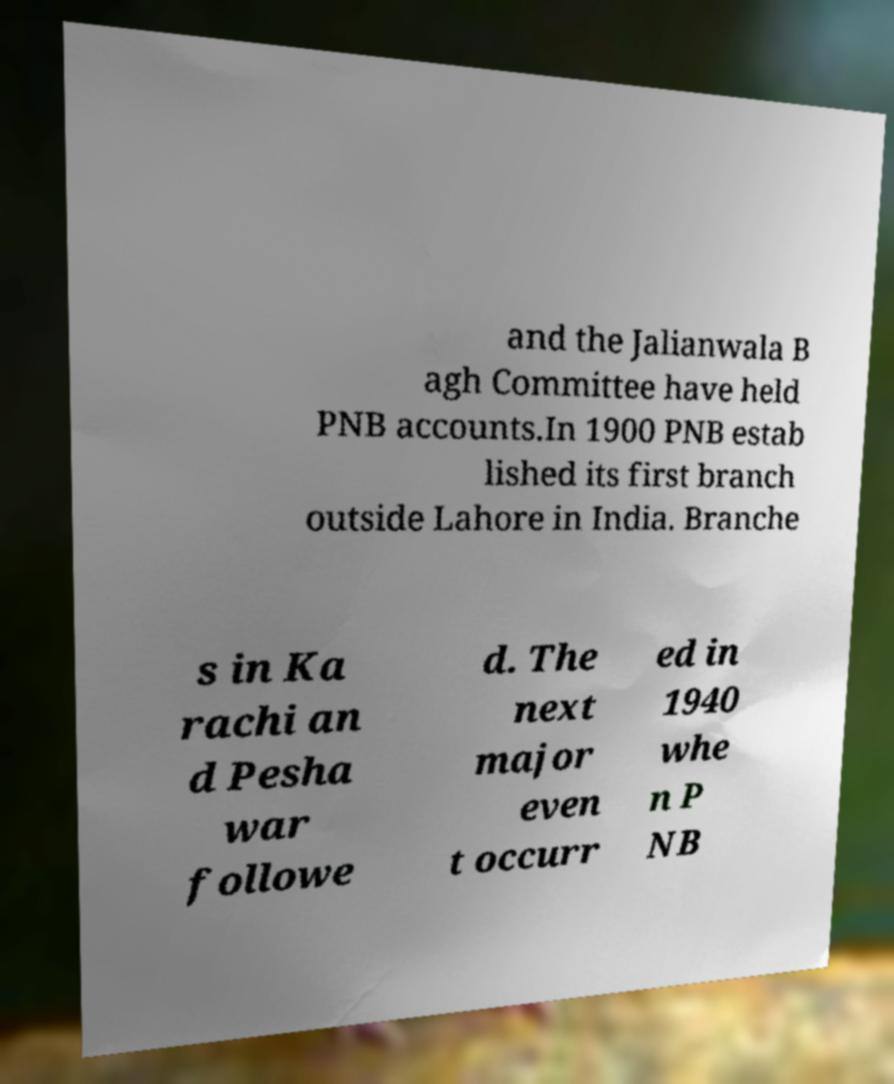Please identify and transcribe the text found in this image. and the Jalianwala B agh Committee have held PNB accounts.In 1900 PNB estab lished its first branch outside Lahore in India. Branche s in Ka rachi an d Pesha war followe d. The next major even t occurr ed in 1940 whe n P NB 